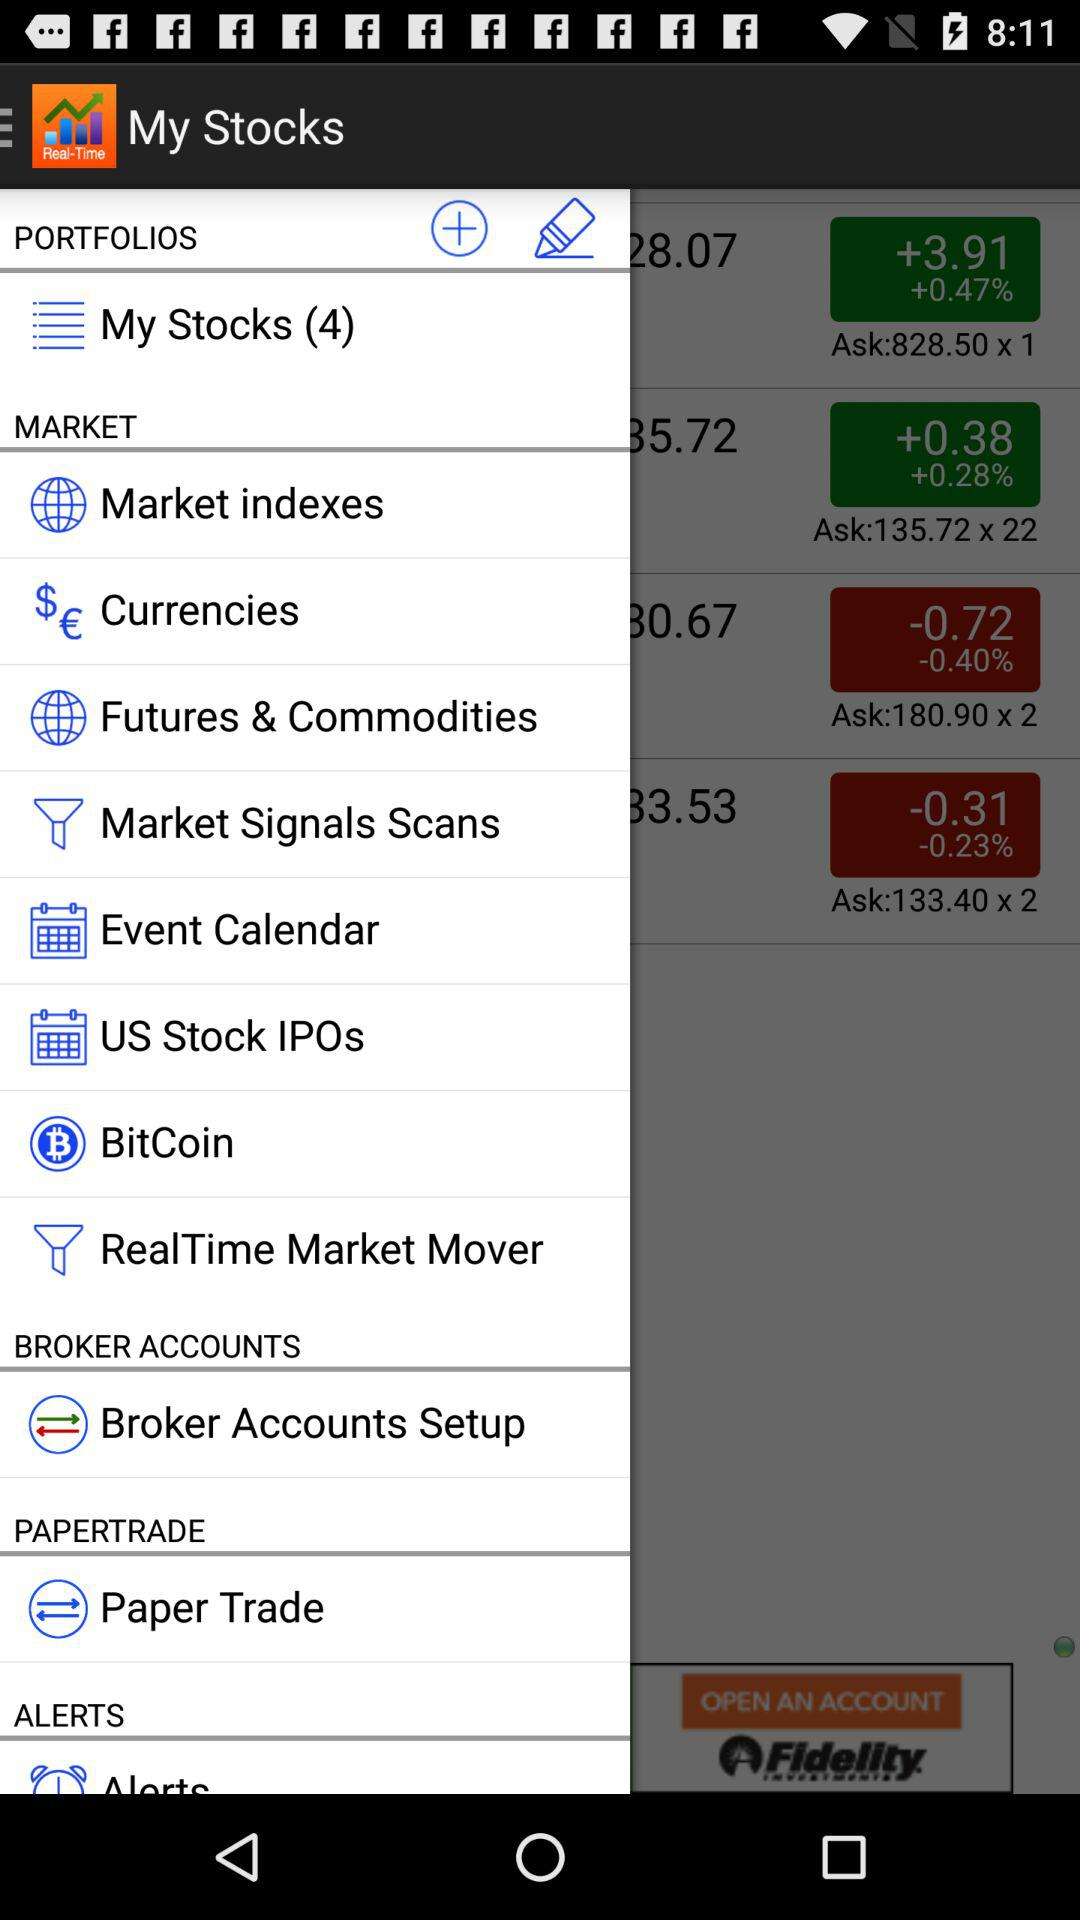What is the name of the application? The name of the application is "My Stocks". 